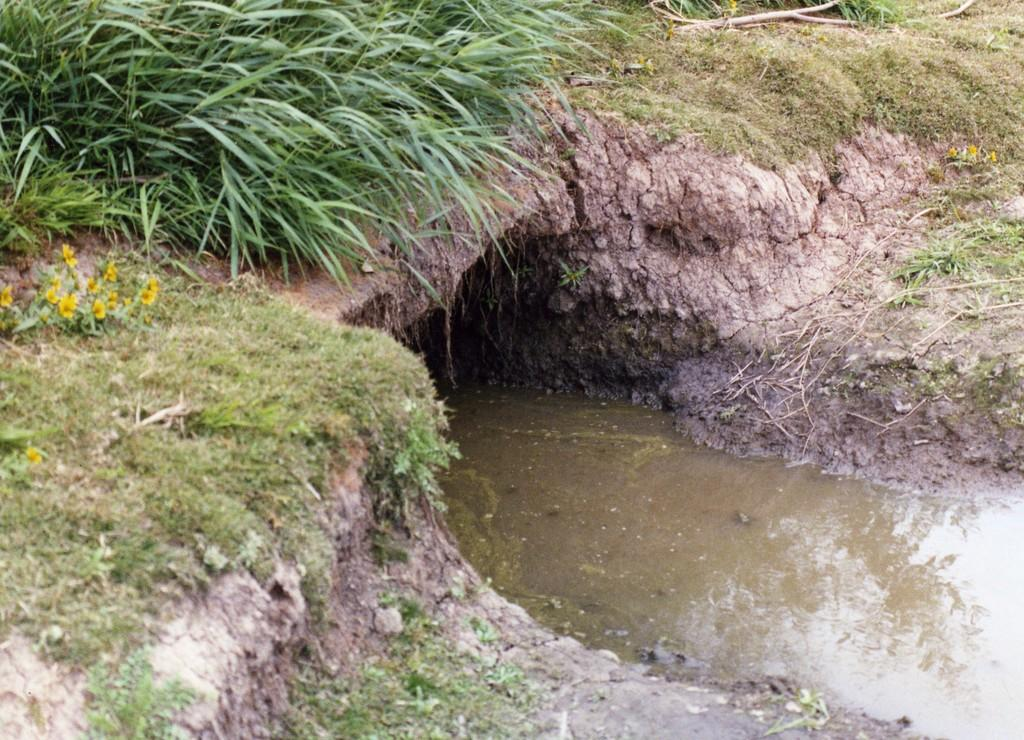What is the main feature in the image? There is a canal in the image. Where are the plants located in the image? The plants are in the top right of the image. What type of mitten is being used to shock the thing in the image? There is no mitten, shock, or thing present in the image. 